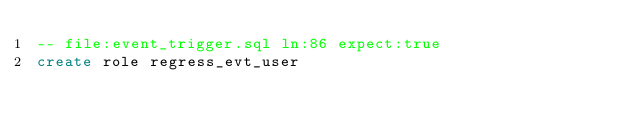Convert code to text. <code><loc_0><loc_0><loc_500><loc_500><_SQL_>-- file:event_trigger.sql ln:86 expect:true
create role regress_evt_user
</code> 